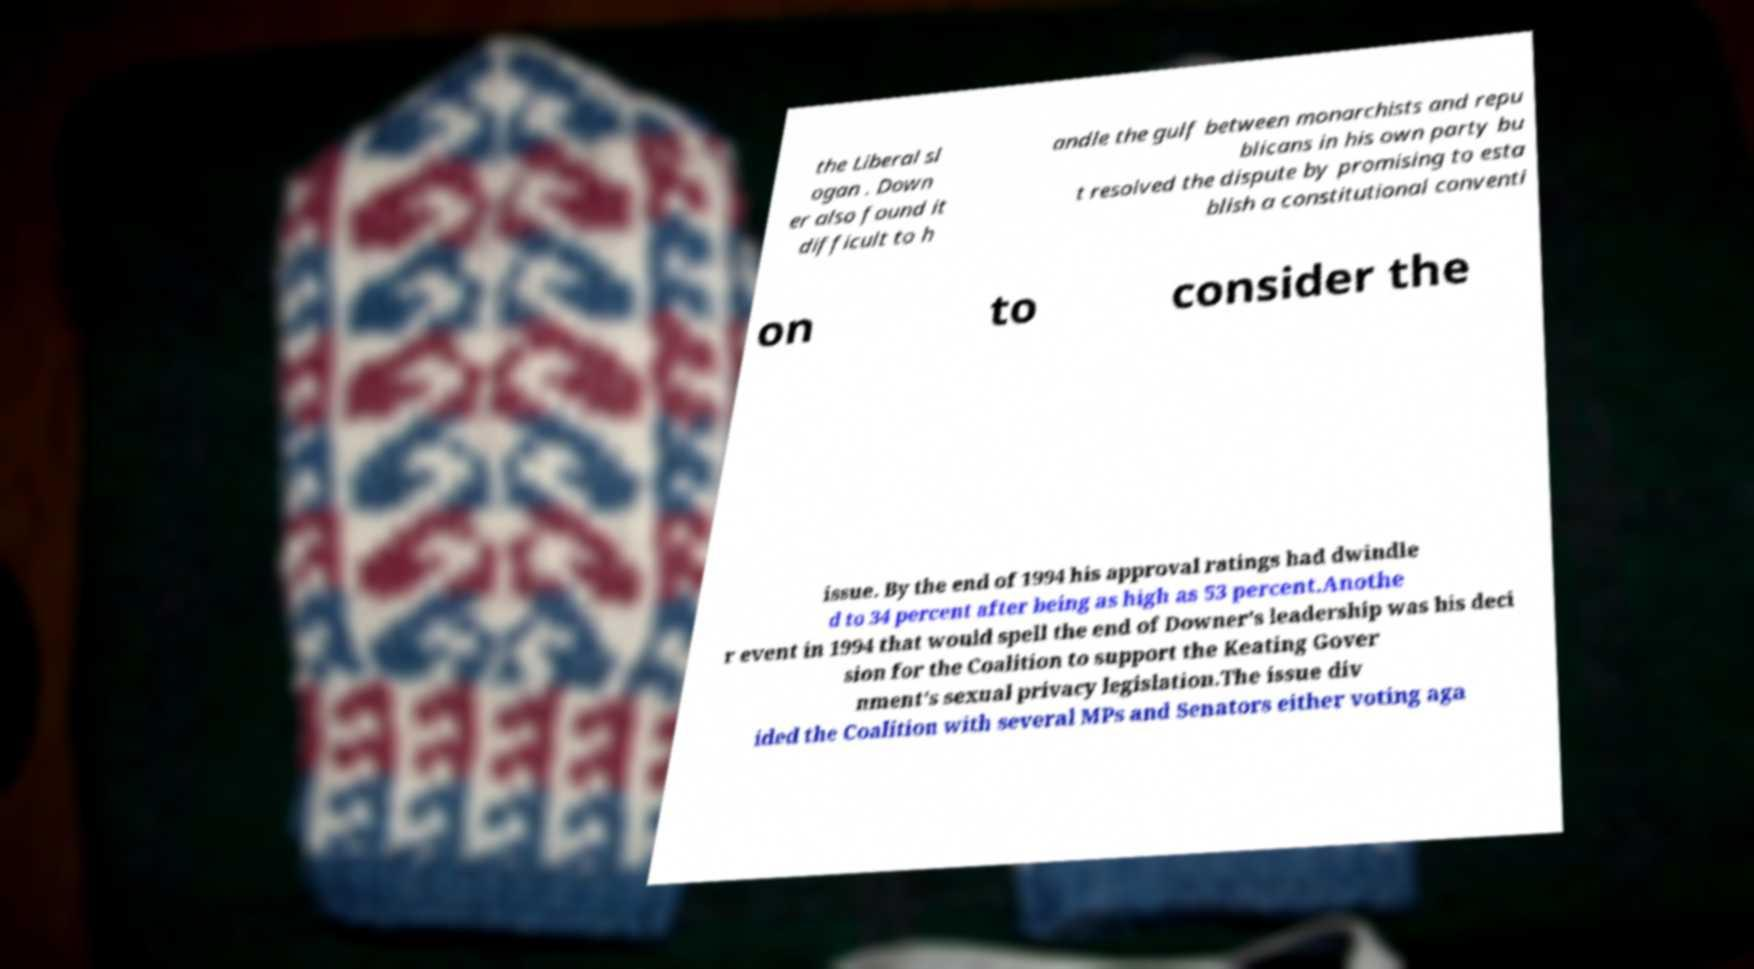Could you extract and type out the text from this image? the Liberal sl ogan . Down er also found it difficult to h andle the gulf between monarchists and repu blicans in his own party bu t resolved the dispute by promising to esta blish a constitutional conventi on to consider the issue. By the end of 1994 his approval ratings had dwindle d to 34 percent after being as high as 53 percent.Anothe r event in 1994 that would spell the end of Downer's leadership was his deci sion for the Coalition to support the Keating Gover nment's sexual privacy legislation.The issue div ided the Coalition with several MPs and Senators either voting aga 